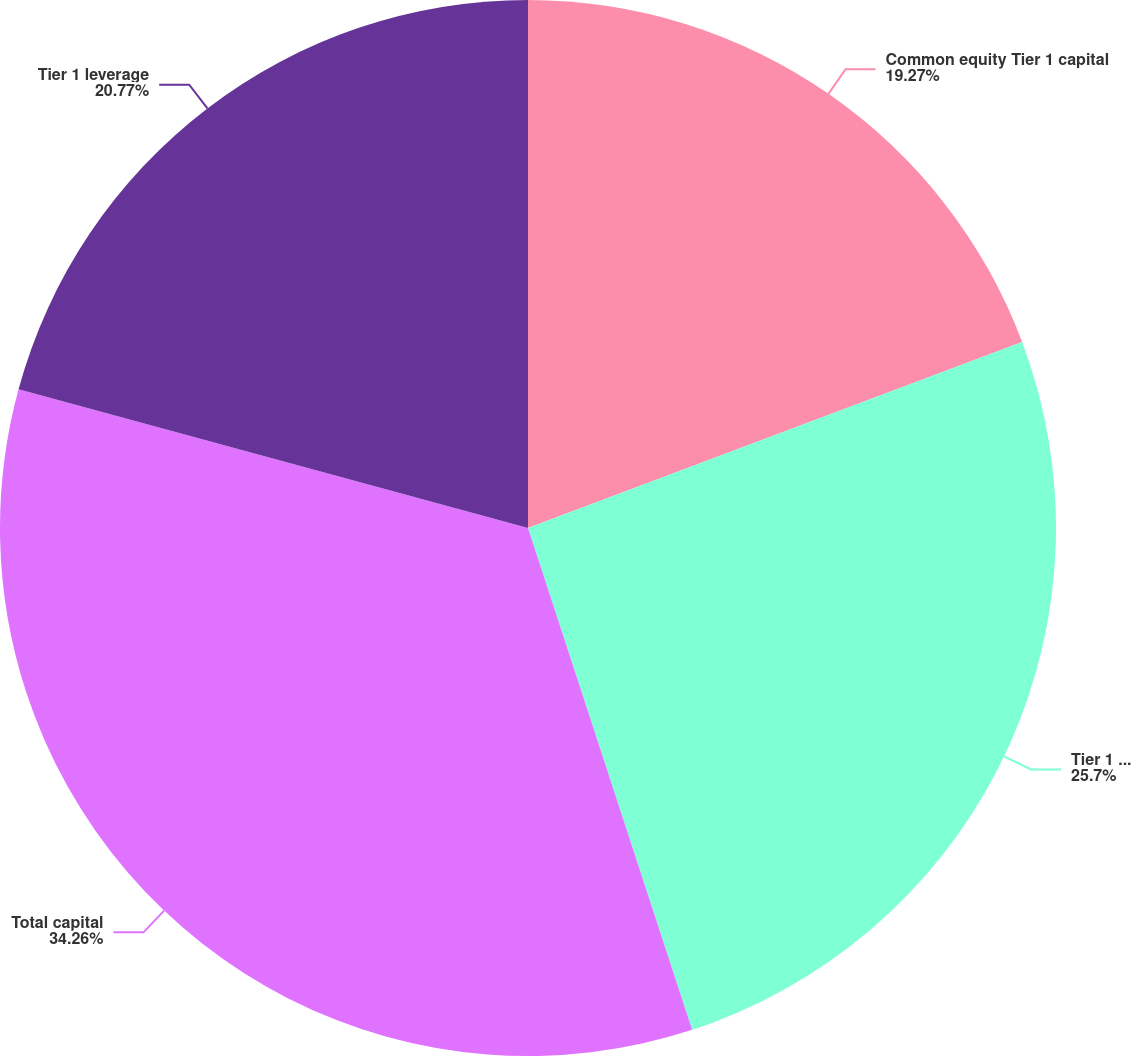<chart> <loc_0><loc_0><loc_500><loc_500><pie_chart><fcel>Common equity Tier 1 capital<fcel>Tier 1 capital<fcel>Total capital<fcel>Tier 1 leverage<nl><fcel>19.27%<fcel>25.7%<fcel>34.26%<fcel>20.77%<nl></chart> 